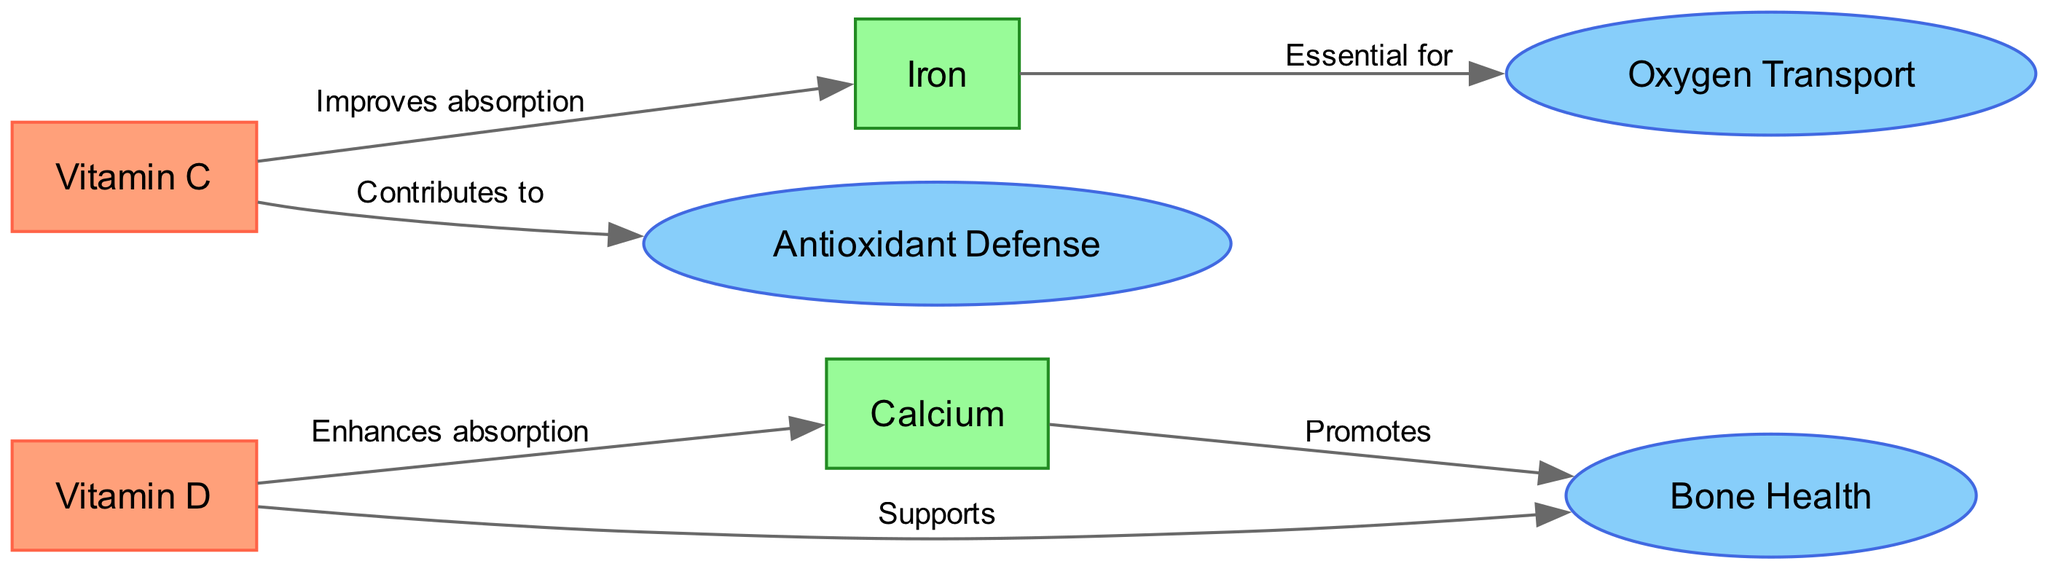What are the total number of nodes in the diagram? There are 7 nodes in total, which include vitamins, minerals, and cellular functions.
Answer: 7 Which vitamin enhances the absorption of calcium? The diagram indicates that Vitamin D enhances the absorption of Calcium, as shown by the directed edge from Vitamin D to Calcium labeled "Enhances absorption."
Answer: Vitamin D What mineral is essential for oxygen transport? Iron is the mineral indicated to be essential for oxygen transport, as shown by the edge pointing from Iron to Oxygen Transport labeled "Essential for."
Answer: Iron What is the relationship between Vitamin C and Iron? The diagram shows that Vitamin C improves the absorption of Iron, represented by the edge from Vitamin C to Iron labeled "Improves absorption."
Answer: Improves absorption How many edges are there that connect cellular functions? There are 3 edges connecting cellular functions in the diagram (Bone Health, Oxygen Transport, and Antioxidant Defense).
Answer: 3 What does Vitamin C contribute to? According to the diagram, Vitamin C contributes to Antioxidant Defense, as indicated by the edge from Vitamin C to Antioxidant Defense labeled "Contributes to."
Answer: Antioxidant Defense How does Calcium affect Bone Health? The connection in the diagram shows that Calcium promotes Bone Health, indicated by the edge from Calcium to Bone Health labeled "Promotes."
Answer: Promotes Which vitamin supports bone health? Vitamin D supports Bone Health, as represented by the edge connecting Vitamin D to Bone Health labeled "Supports."
Answer: Supports Which two nodes have a direct interaction in the context of enhancing absorption? The two nodes are Vitamin D and Calcium, with the interaction labeled "Enhances absorption" indicated in the diagram.
Answer: Vitamin D and Calcium 